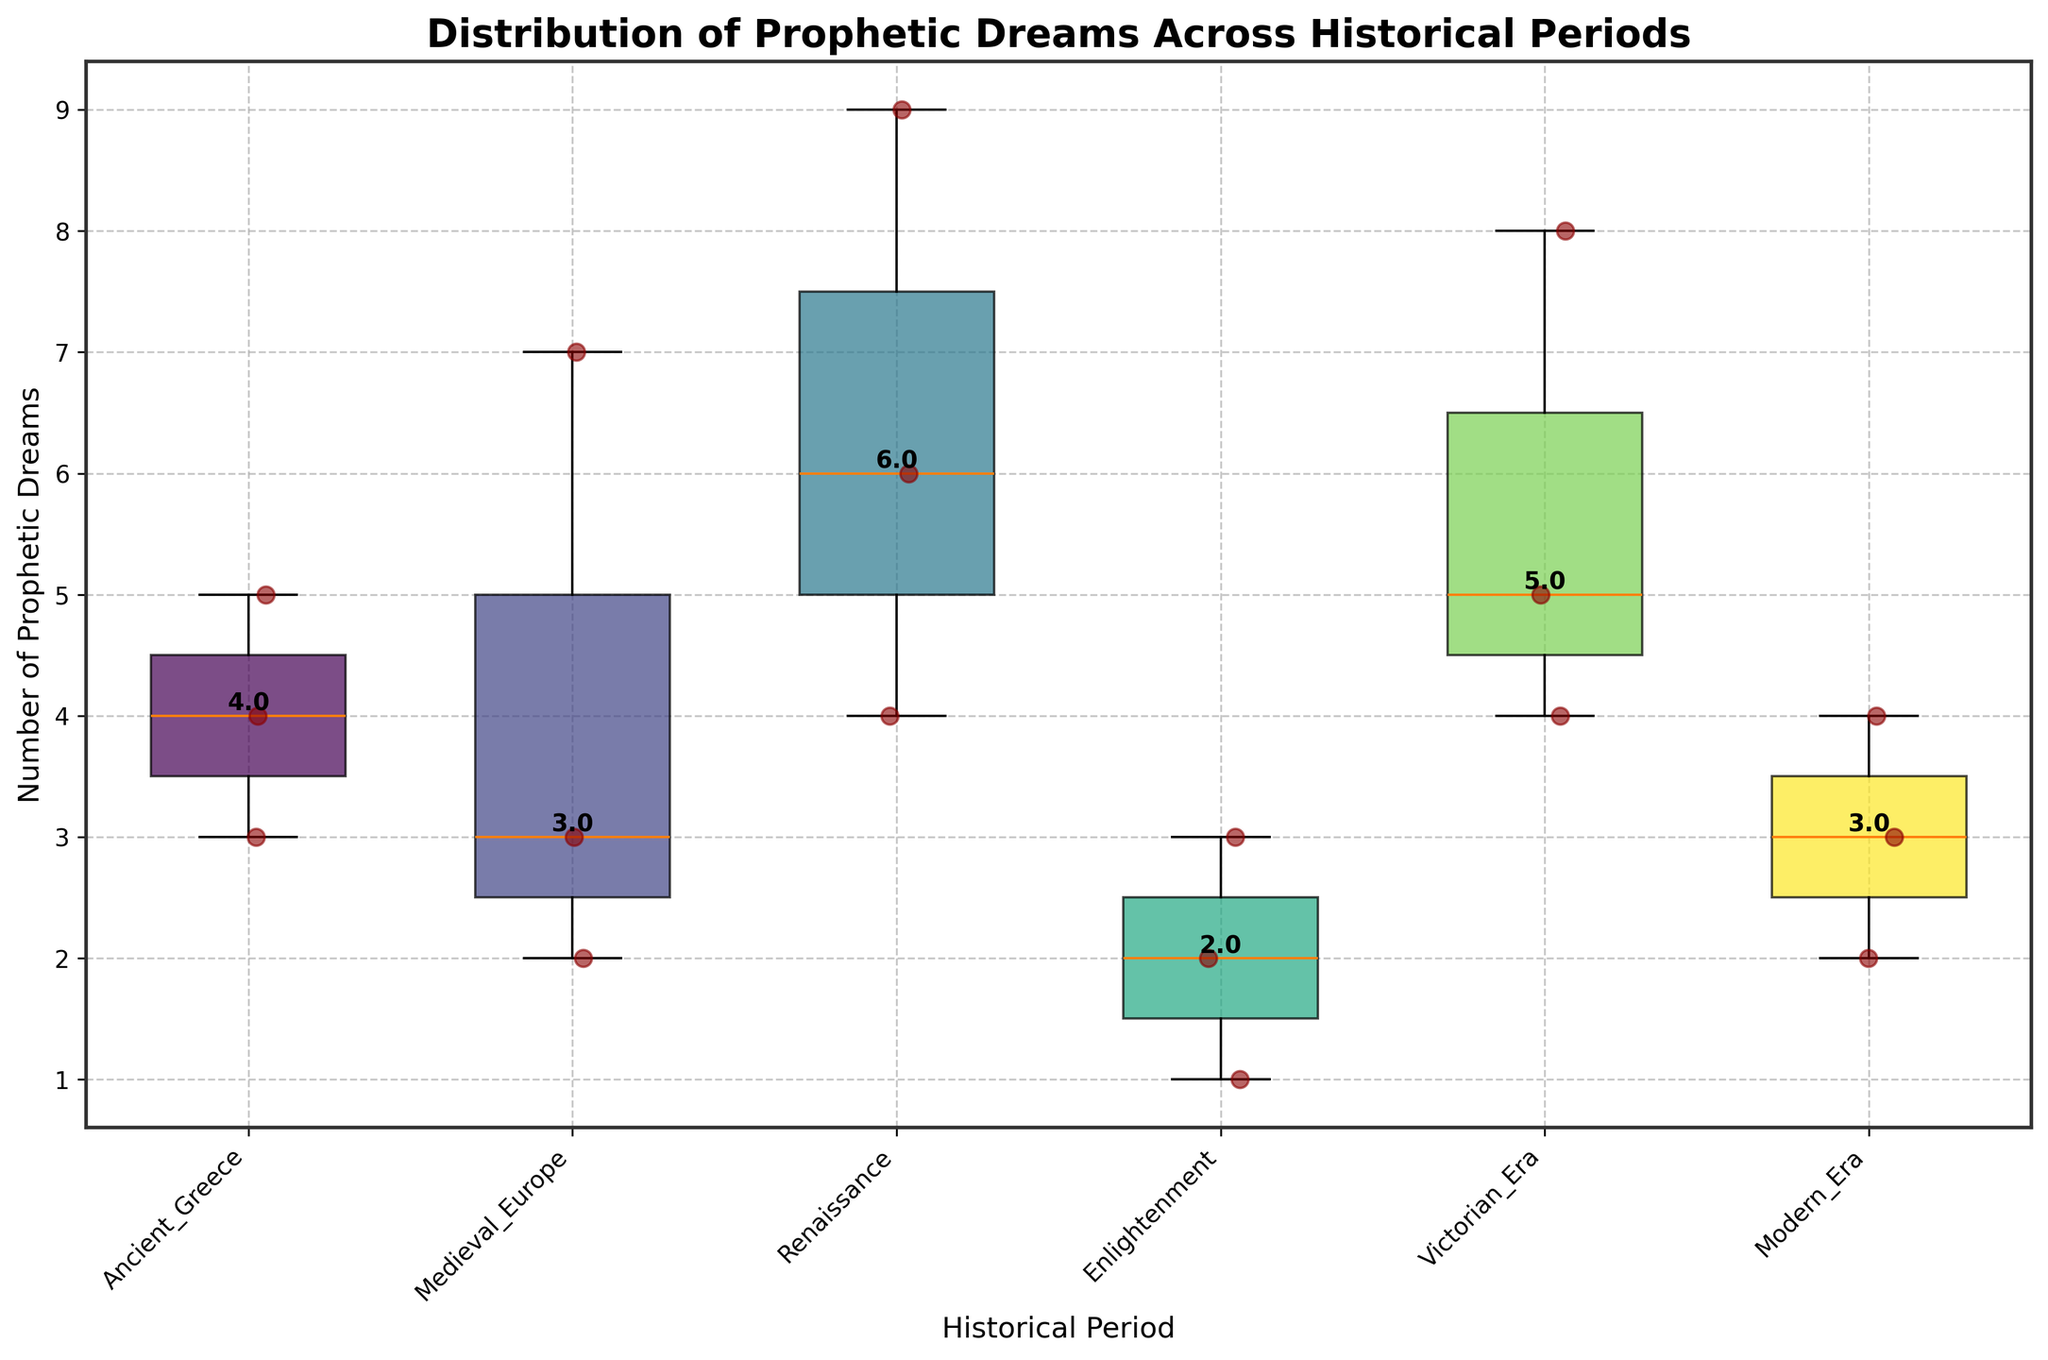What is the title of the plot? The title of the plot is written at the top and summarizes the content of the figure. It is usually the most distinct text in the plot.
Answer: Distribution of Prophetic Dreams Across Historical Periods What is the highest number of prophetic dreams recorded for a single mortal, and during which period did it occur? First, identify the highest data point in the scatter plots for each historical period. The highest point appears in the Renaissance period for Nostradamus.
Answer: 9, Renaissance Which historical period has the lowest median number of prophetic dreams? The median value for each historical period is annotated on the plot. The lowest median is found by comparing these values.
Answer: Enlightenment How many historical periods are represented in the plot? Each unique historical period is represented on the x-axis with labels, which can be counted.
Answer: 6 Rank the historical periods based on their median values of prophetic dreams in ascending order. Use the median values annotated for each period and sort them from the smallest to the largest.
Answer: Enlightenment, Modern Era, Ancient Greece, Medieval Europe, Victorian Era, Renaissance Which historical period shows the most variation in the number of prophetic dreams? Variation can be inferred from the width of the interquartile range (IQR) and the range of the whiskers in the box plots. The period with the widest IQR or longest whiskers has the most variation.
Answer: Medieval Europe Which periods have an outlier, and what are the values of those outliers? Outliers in a box plot are usually points that are detached from the main box and whiskers. Check for scattered points distinctly farther from the box.
Answer: Modern Era (1), Victorian Era (8) Are the number of prophetic dreams experienced by mortals generally higher in earlier periods (Ancient Greece, Medieval Europe) compared to later periods (Enlightenment, Modern Era)? Evaluate the median values and distribution spread across the periods. Compare values of earlier periods to those of later periods.
Answer: No What is the median number of prophetic dreams in the Victorian Era, and how does it compare to that in the Medieval European period? The median values are annotated on the plot. Compare the two medians directly.
Answer: 5 for Victorian Era, 3 for Medieval Europe. Victorian Era is higher 